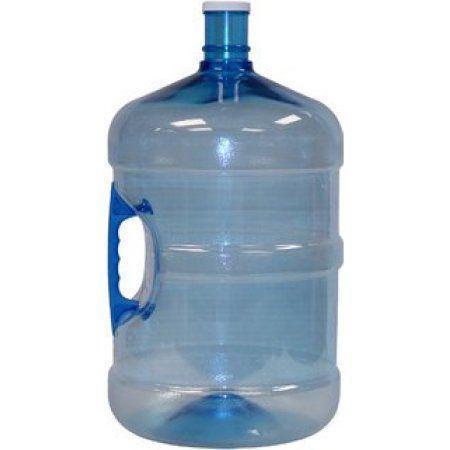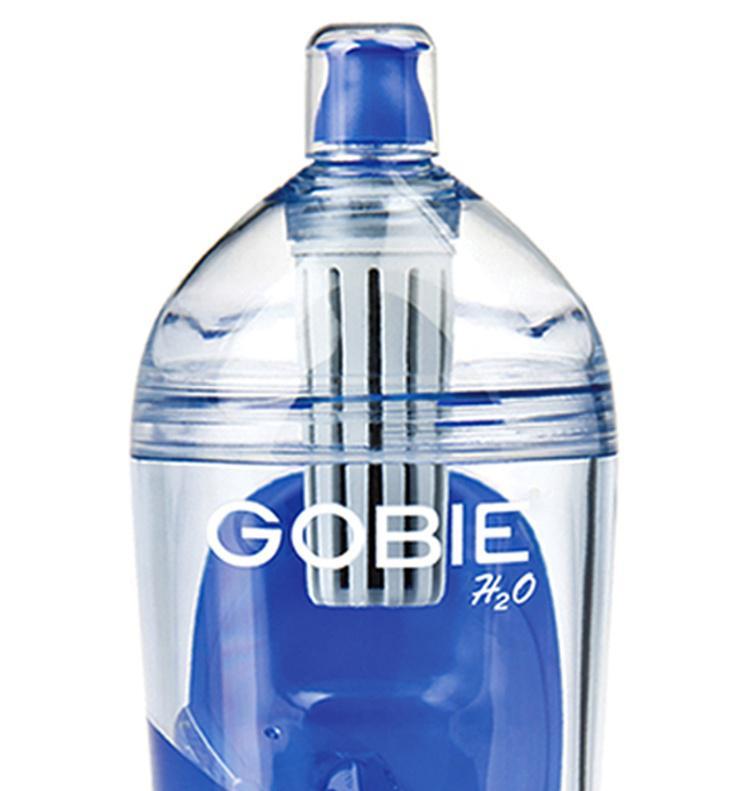The first image is the image on the left, the second image is the image on the right. Considering the images on both sides, is "An image includes a smaller handled jug next to a larger water jug with handle visible." valid? Answer yes or no. No. The first image is the image on the left, the second image is the image on the right. Assess this claim about the two images: "Exactly four blue tinted plastic bottles are shown, two with a hand grip in the side of the bottle, and two with no grips.". Correct or not? Answer yes or no. No. 